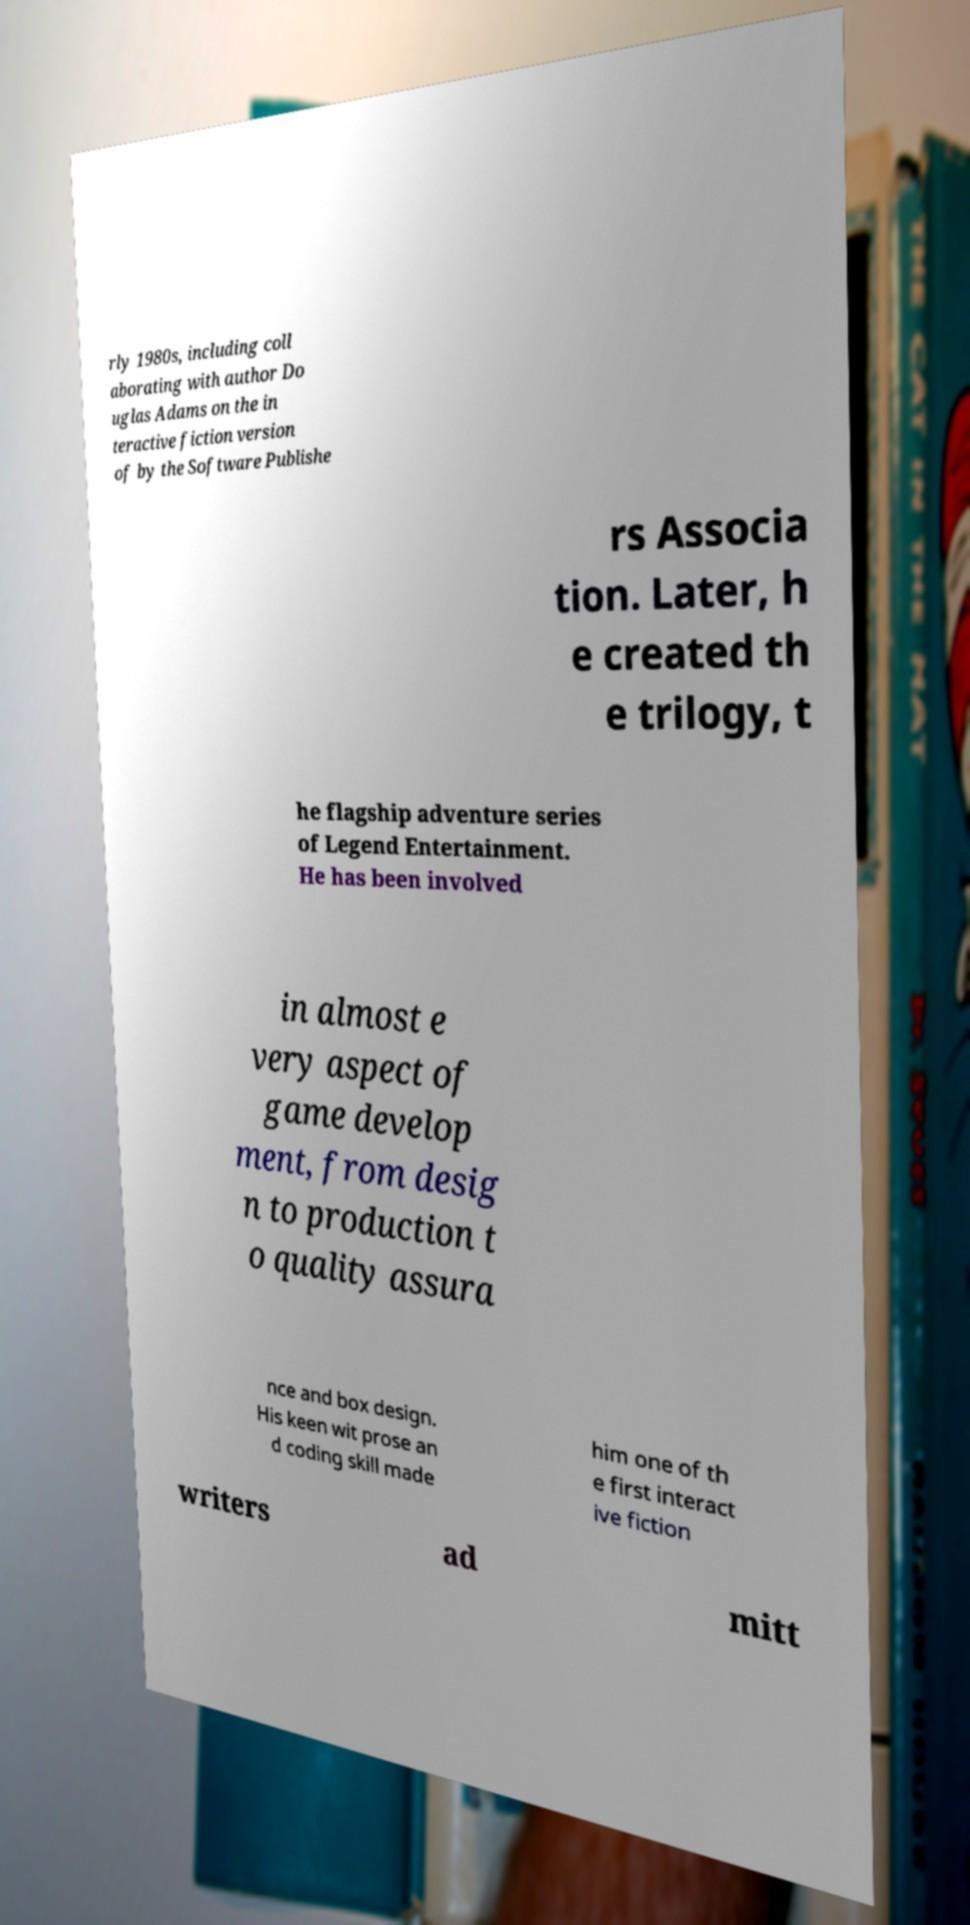For documentation purposes, I need the text within this image transcribed. Could you provide that? rly 1980s, including coll aborating with author Do uglas Adams on the in teractive fiction version of by the Software Publishe rs Associa tion. Later, h e created th e trilogy, t he flagship adventure series of Legend Entertainment. He has been involved in almost e very aspect of game develop ment, from desig n to production t o quality assura nce and box design. His keen wit prose an d coding skill made him one of th e first interact ive fiction writers ad mitt 